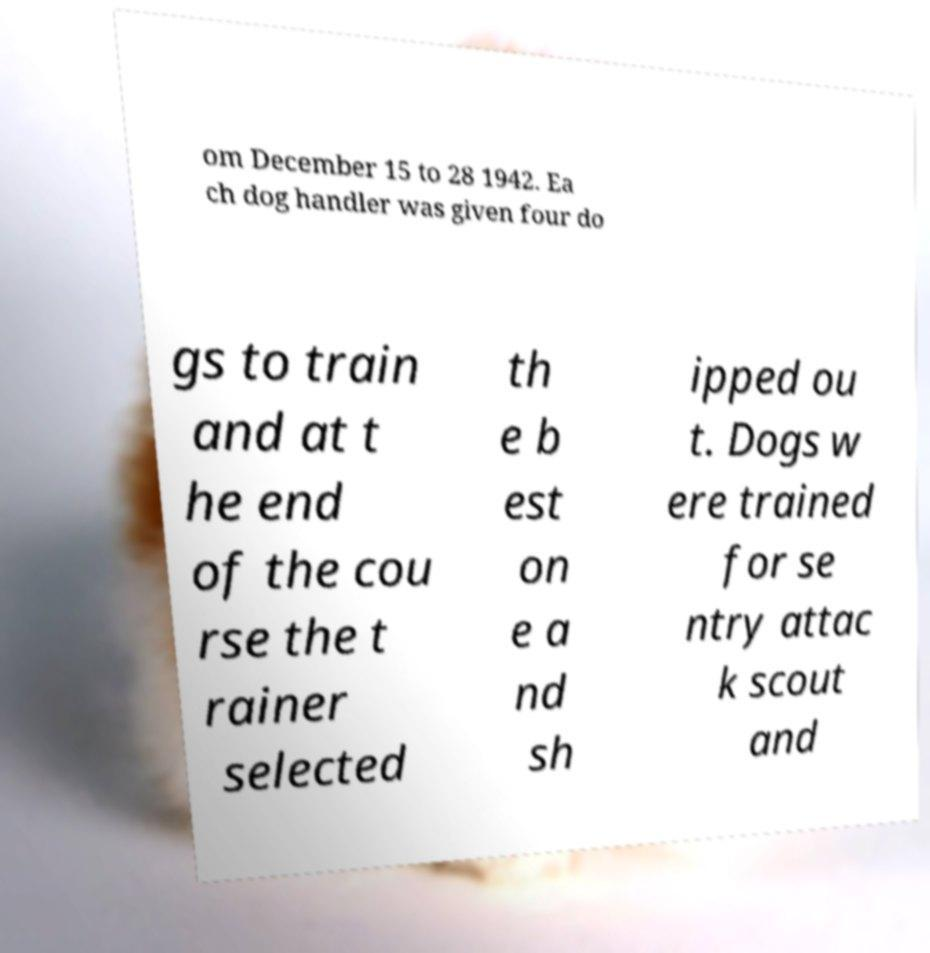Please identify and transcribe the text found in this image. om December 15 to 28 1942. Ea ch dog handler was given four do gs to train and at t he end of the cou rse the t rainer selected th e b est on e a nd sh ipped ou t. Dogs w ere trained for se ntry attac k scout and 